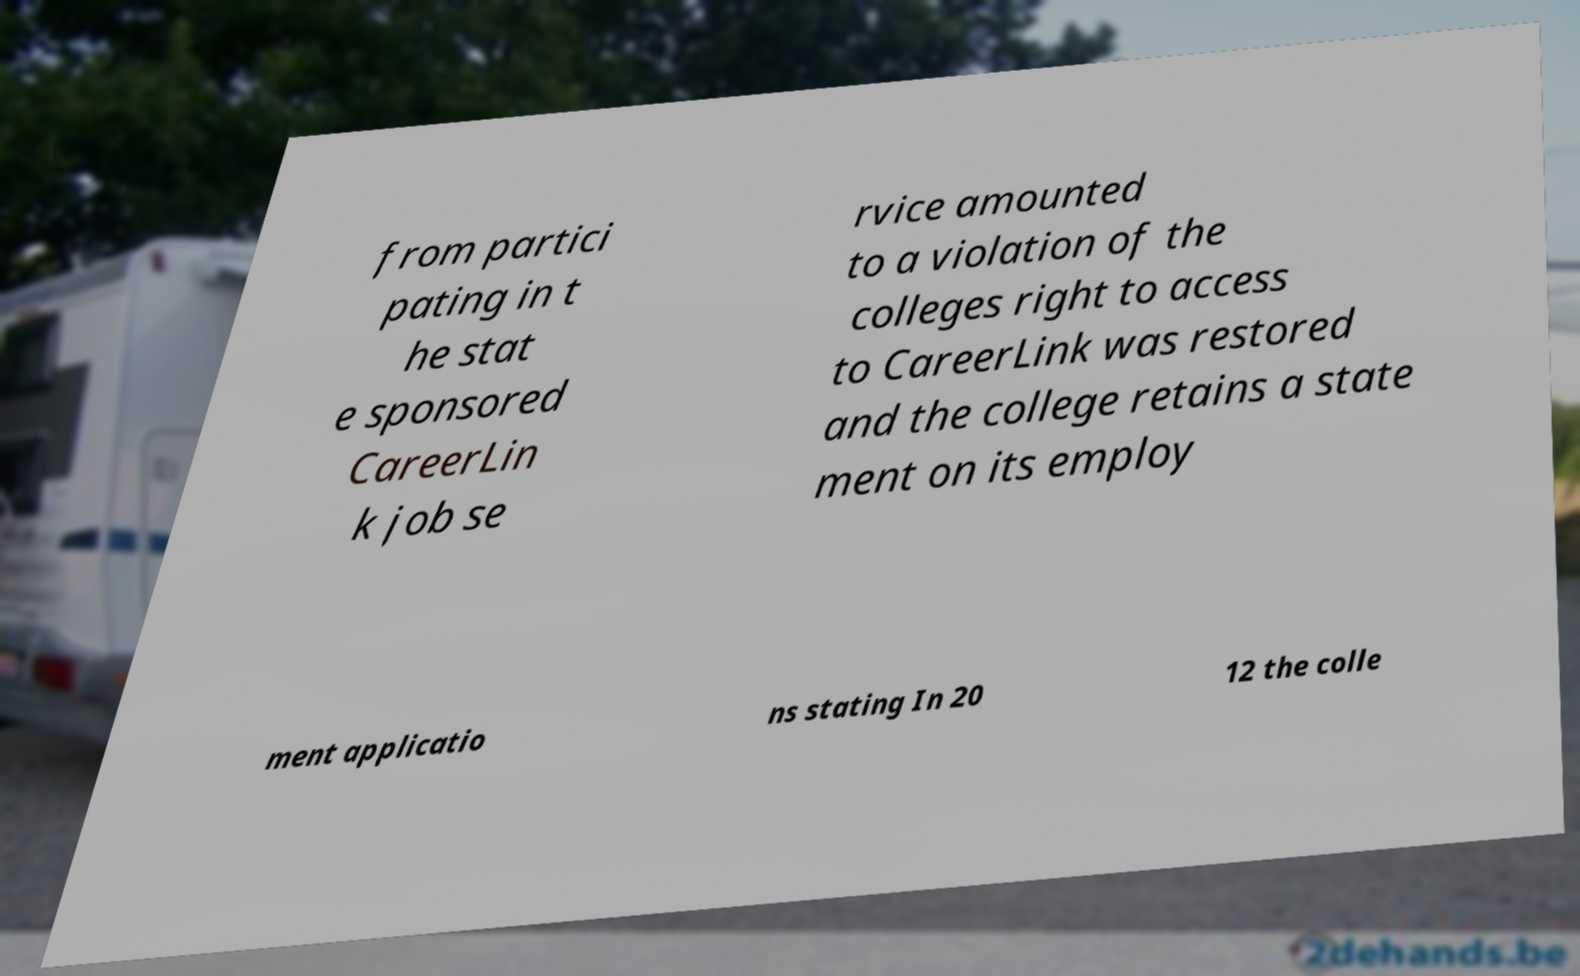Can you accurately transcribe the text from the provided image for me? from partici pating in t he stat e sponsored CareerLin k job se rvice amounted to a violation of the colleges right to access to CareerLink was restored and the college retains a state ment on its employ ment applicatio ns stating In 20 12 the colle 